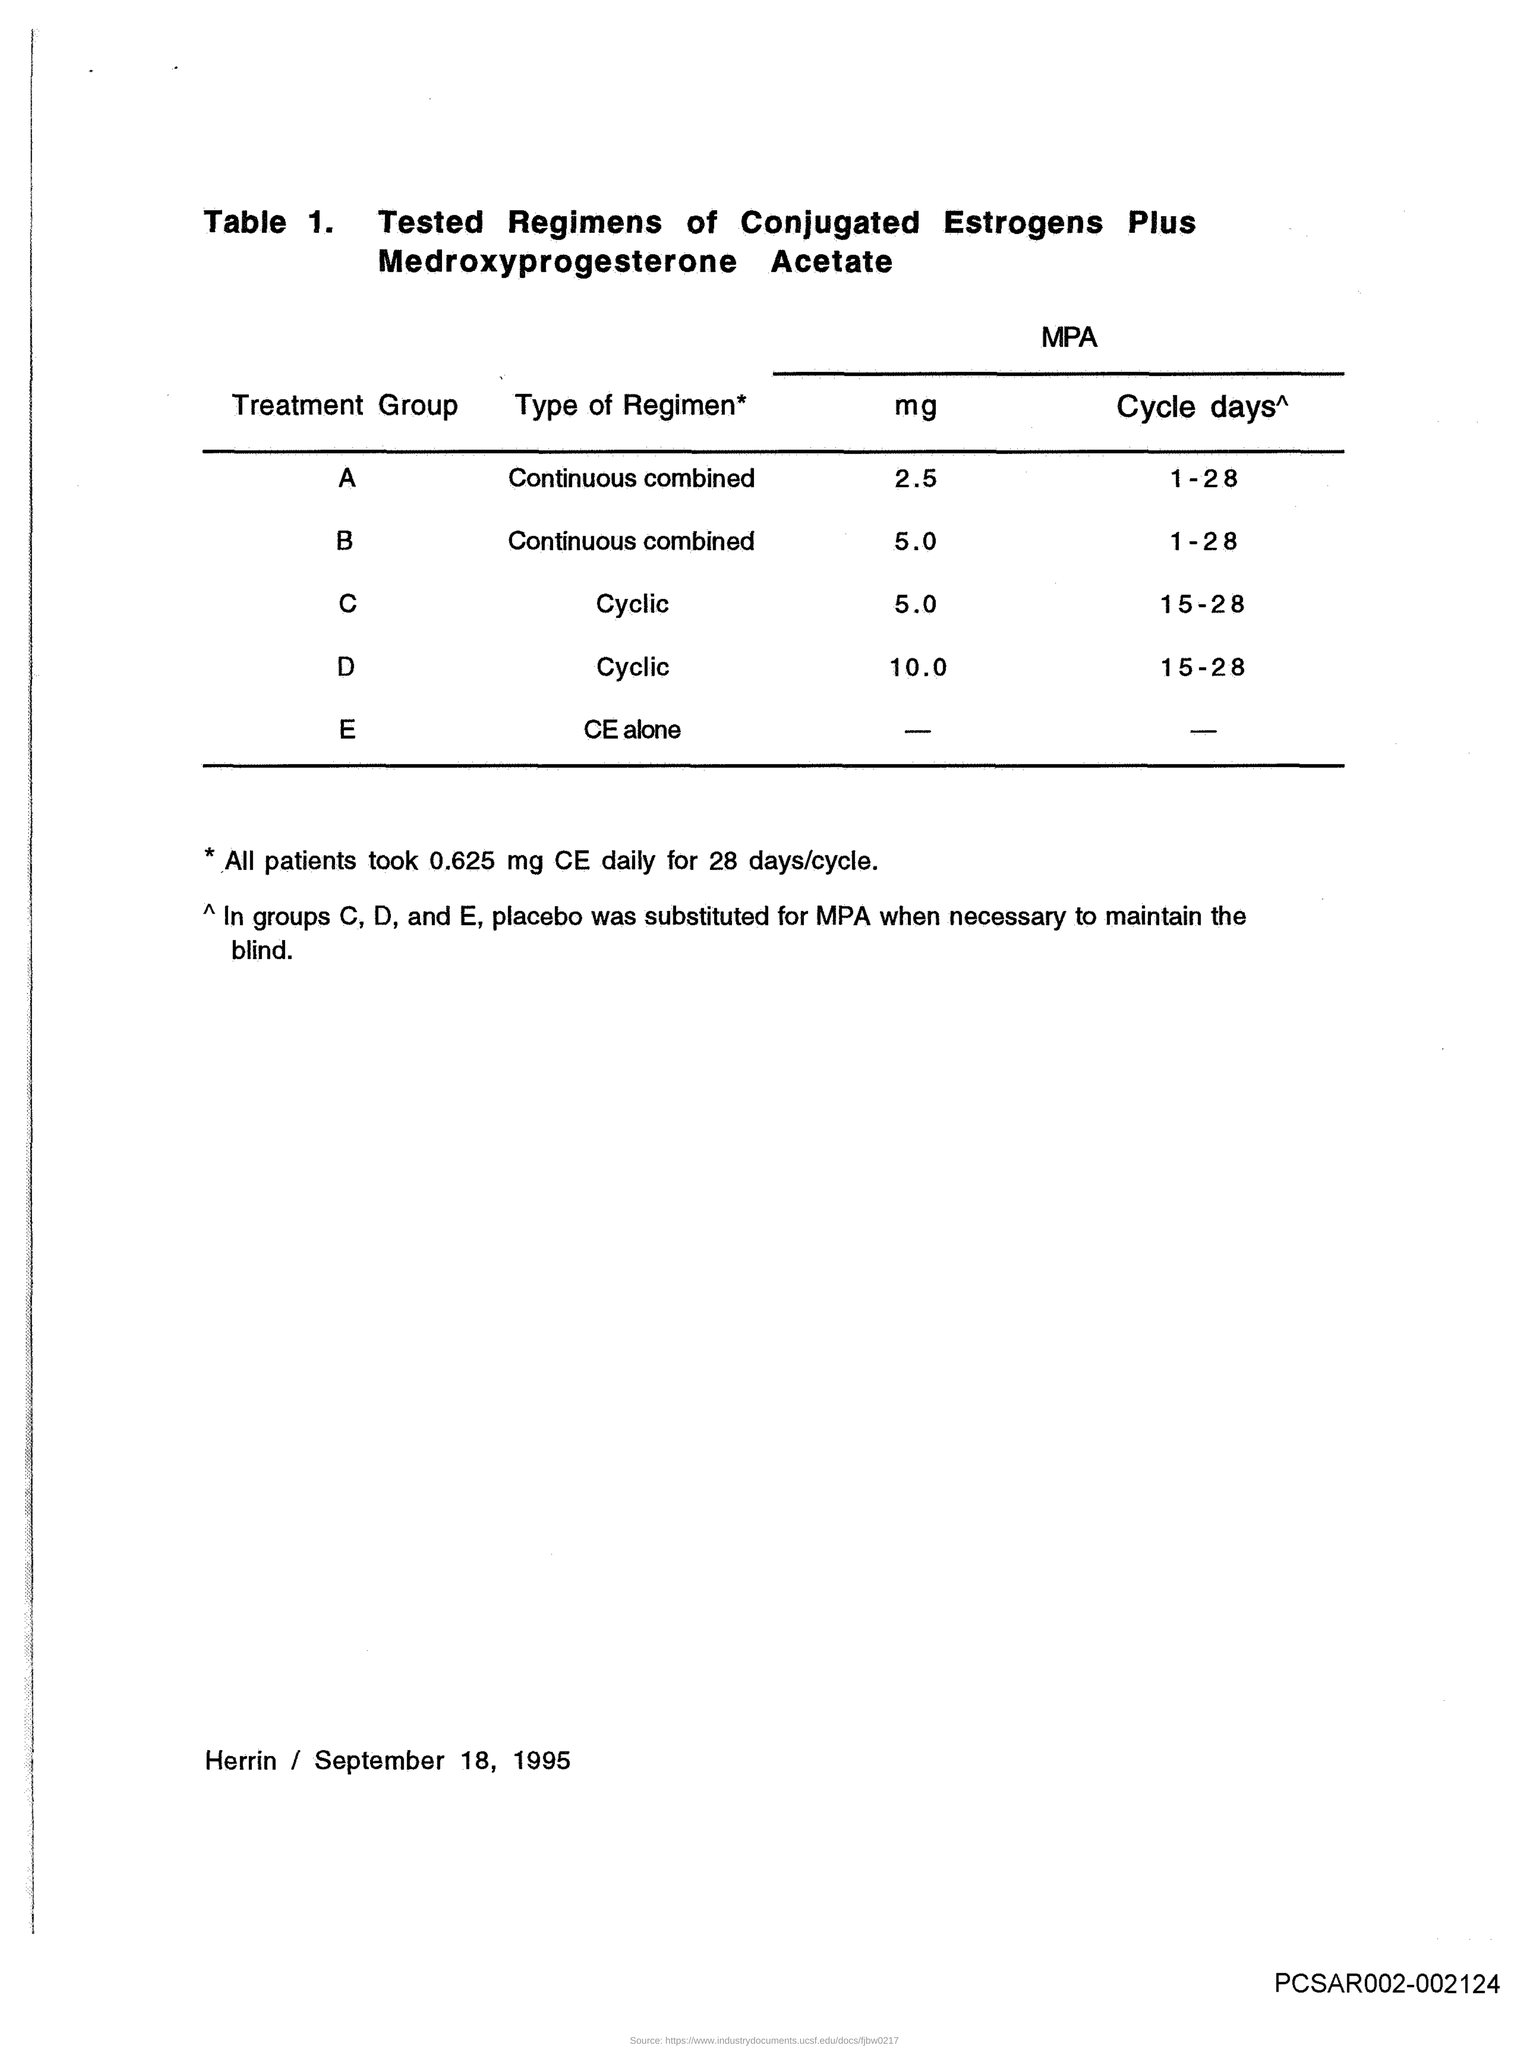What is the MPA-mg for treatment group A?
Provide a succinct answer. 2.5. What is the MPA-mg for treatment group B?
Ensure brevity in your answer.  5.0. What is the MPA-mg for treatment group C?
Your response must be concise. 5.0. What is the MPA-mg for treatment group D?
Your response must be concise. 10.0. What is the MPA-Cycle days for treatment group A?
Offer a very short reply. 1-28. What is the MPA-Cycle days for treatment group B?
Your response must be concise. 1-28. What is the MPA-Cycle days for treatment group C?
Provide a succinct answer. 15-28. What is the MPA-Cycle days for treatment group D?
Make the answer very short. 15-28. How much CE did all patients take?
Your answer should be very brief. 0.625 mg. 